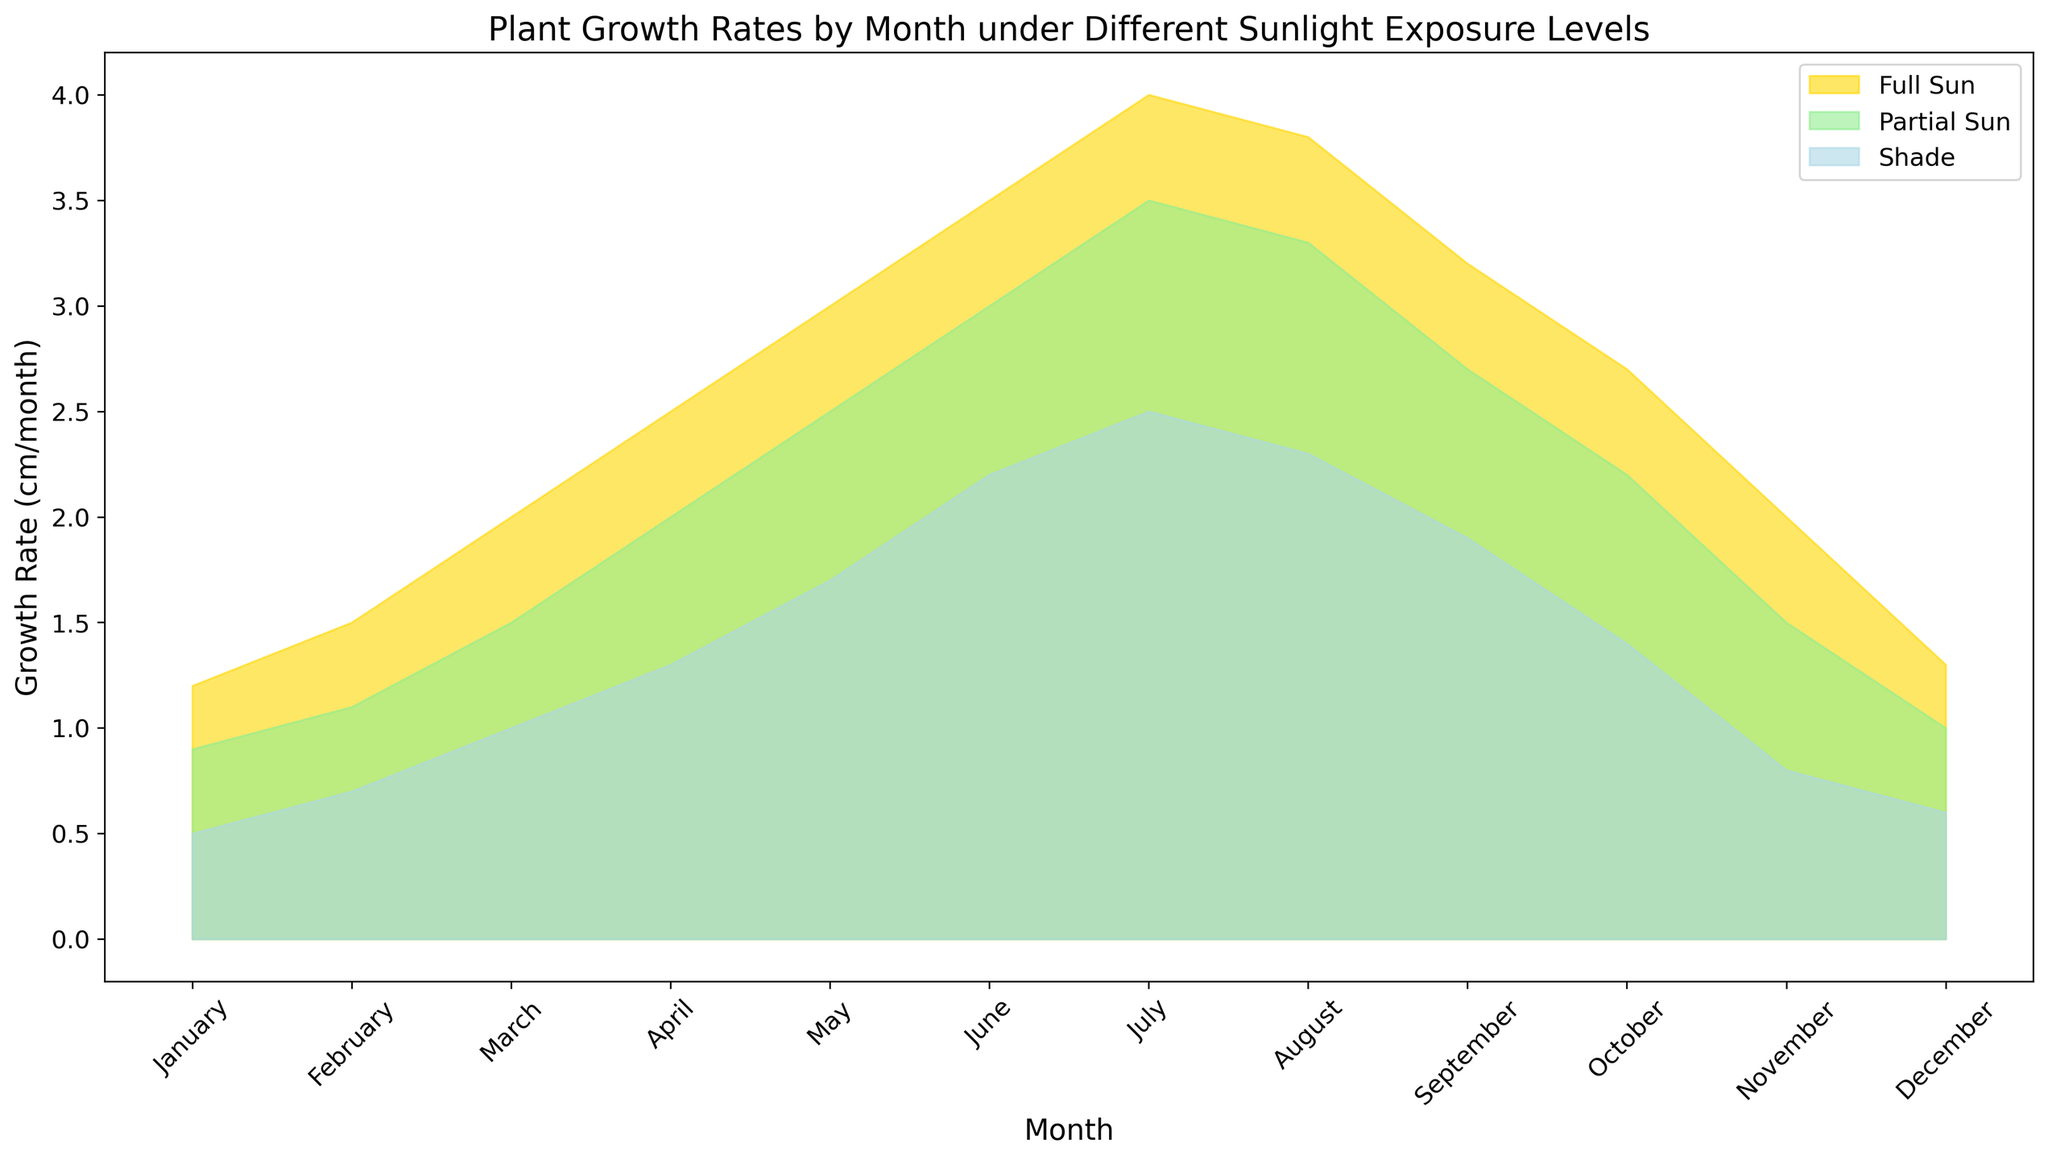Which month has the highest plant growth rate in full sun conditions? Look for the tallest area (gold segment) which represents full sun growth. The highest point is in July.
Answer: July How does the growth rate in partial sun compare to shade in June? Locate both the green and light blue segments for June. The green segment (partial sun) is higher, indicative of a greater growth rate compared to the light blue segment (shade).
Answer: Partial sun is higher What's the overall trend of plant growth rates under full sun from January to December? Examine the pattern of the gold segment from January to December. The growth increases steadily until July, then it starts to decline gradually.
Answer: Increases until July, then decreases By how much does the growth rate in full sun in July exceed that in January? Note the difference between the heights of the gold segment in January (1.2 cm/month) and July (4.0 cm/month). Subtract 1.2 from 4.0.
Answer: 2.8 cm/month In which month does the growth rate under partial sun reach 3 cm/month, and how does this compare to full sun in the same month? Identify where the green segment reaches 3 cm/month, which is in June. Compare with the gold segment for the same month, where full sun is at 3.5 cm/month.
Answer: June; full sun is higher by 0.5 cm/month Does the plant growth rate in the shade ever exceed 2 cm/month? Check the height of the light blue segment throughout the chart. Notice it never reaches or exceeds 2 cm/month.
Answer: No During which months does the plant growth rate in full sun surpass 3 cm/month? Identify the months where the gold segment's height is above the 3 cm/month mark, specifically in May, June, July, and August.
Answer: May, June, July, August Compare the growth rates of plants in shade to those in partial sun in November. Locate the height of both the light blue and green segments for November. The green segment (partial sun) is visibly taller than the blue segment (shade).
Answer: Partial sun is higher What is the total growth rate in August, adding up all sunlight conditions? Sum the growth rates for August: full sun (3.8 cm/month), partial sun (3.3 cm/month), and shade (2.3 cm/month). This totals 9.4 cm/month.
Answer: 9.4 cm/month 